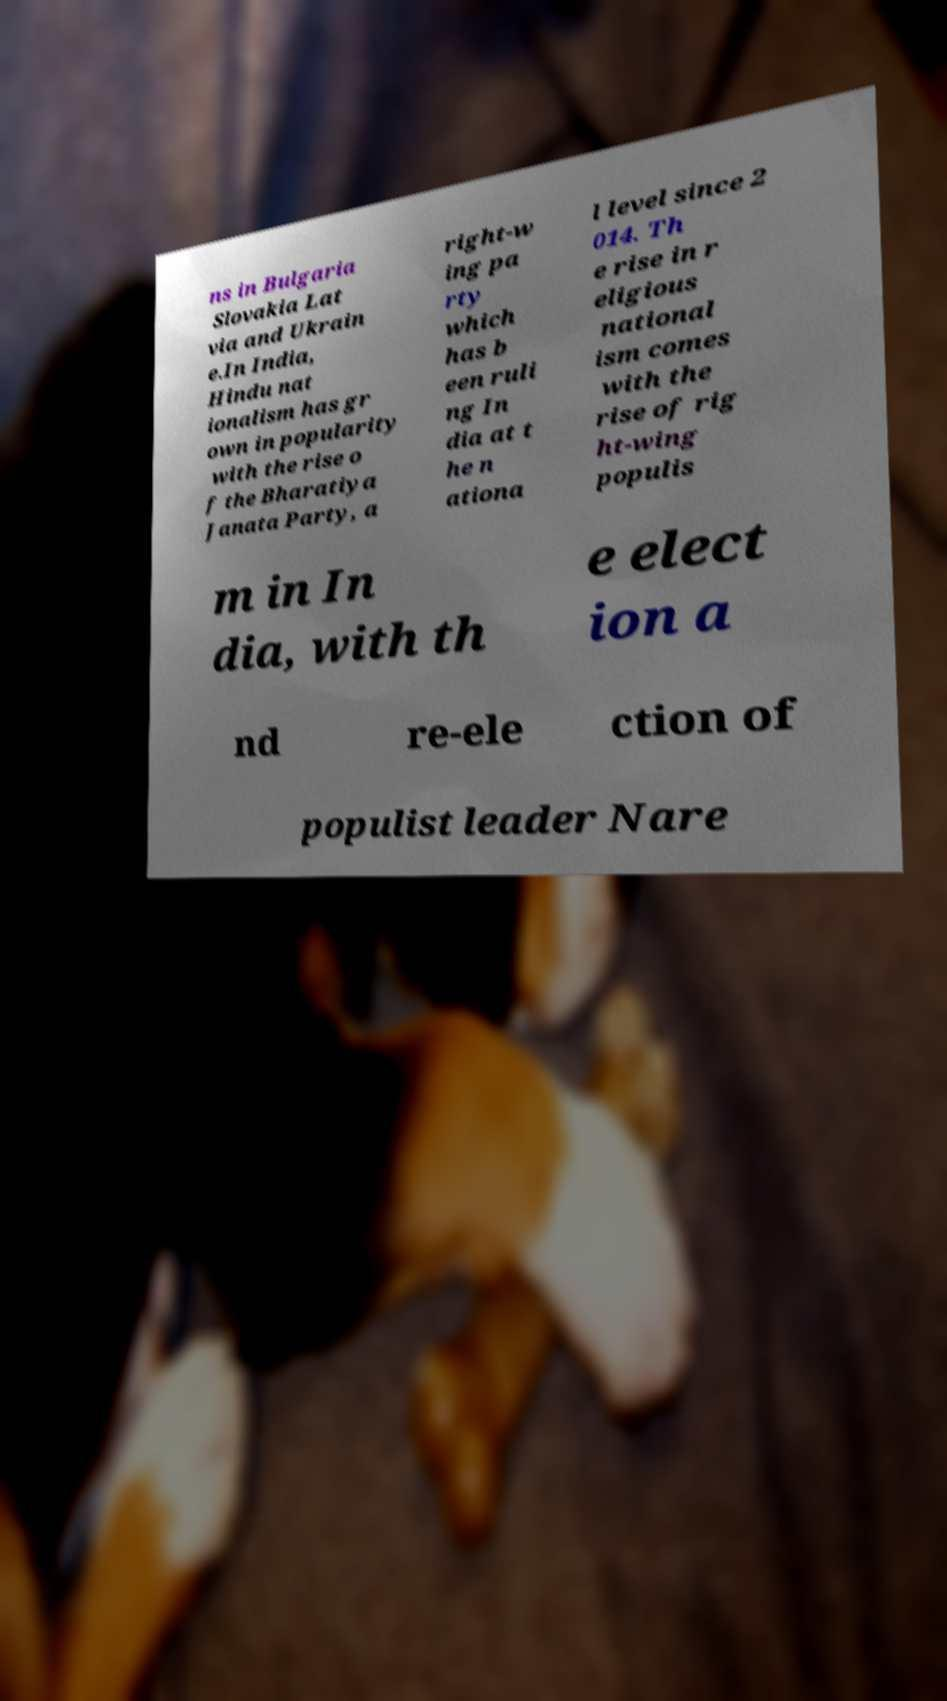Can you read and provide the text displayed in the image?This photo seems to have some interesting text. Can you extract and type it out for me? ns in Bulgaria Slovakia Lat via and Ukrain e.In India, Hindu nat ionalism has gr own in popularity with the rise o f the Bharatiya Janata Party, a right-w ing pa rty which has b een ruli ng In dia at t he n ationa l level since 2 014. Th e rise in r eligious national ism comes with the rise of rig ht-wing populis m in In dia, with th e elect ion a nd re-ele ction of populist leader Nare 